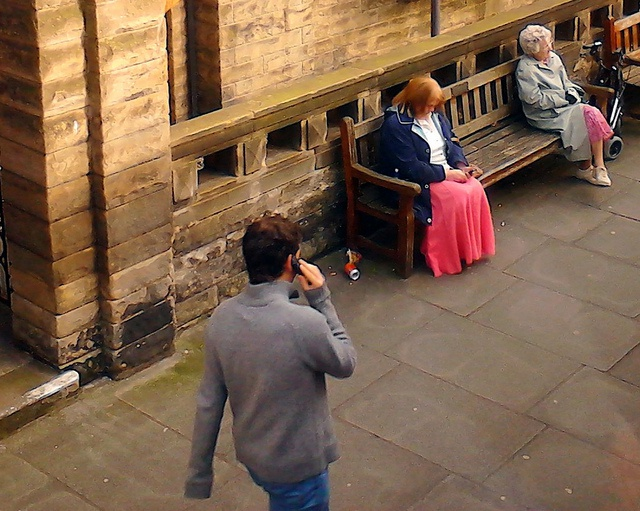Describe the objects in this image and their specific colors. I can see people in maroon, gray, and black tones, bench in maroon, black, and gray tones, people in maroon, black, salmon, and brown tones, people in maroon, darkgray, gray, brown, and black tones, and bench in maroon, black, brown, and tan tones in this image. 